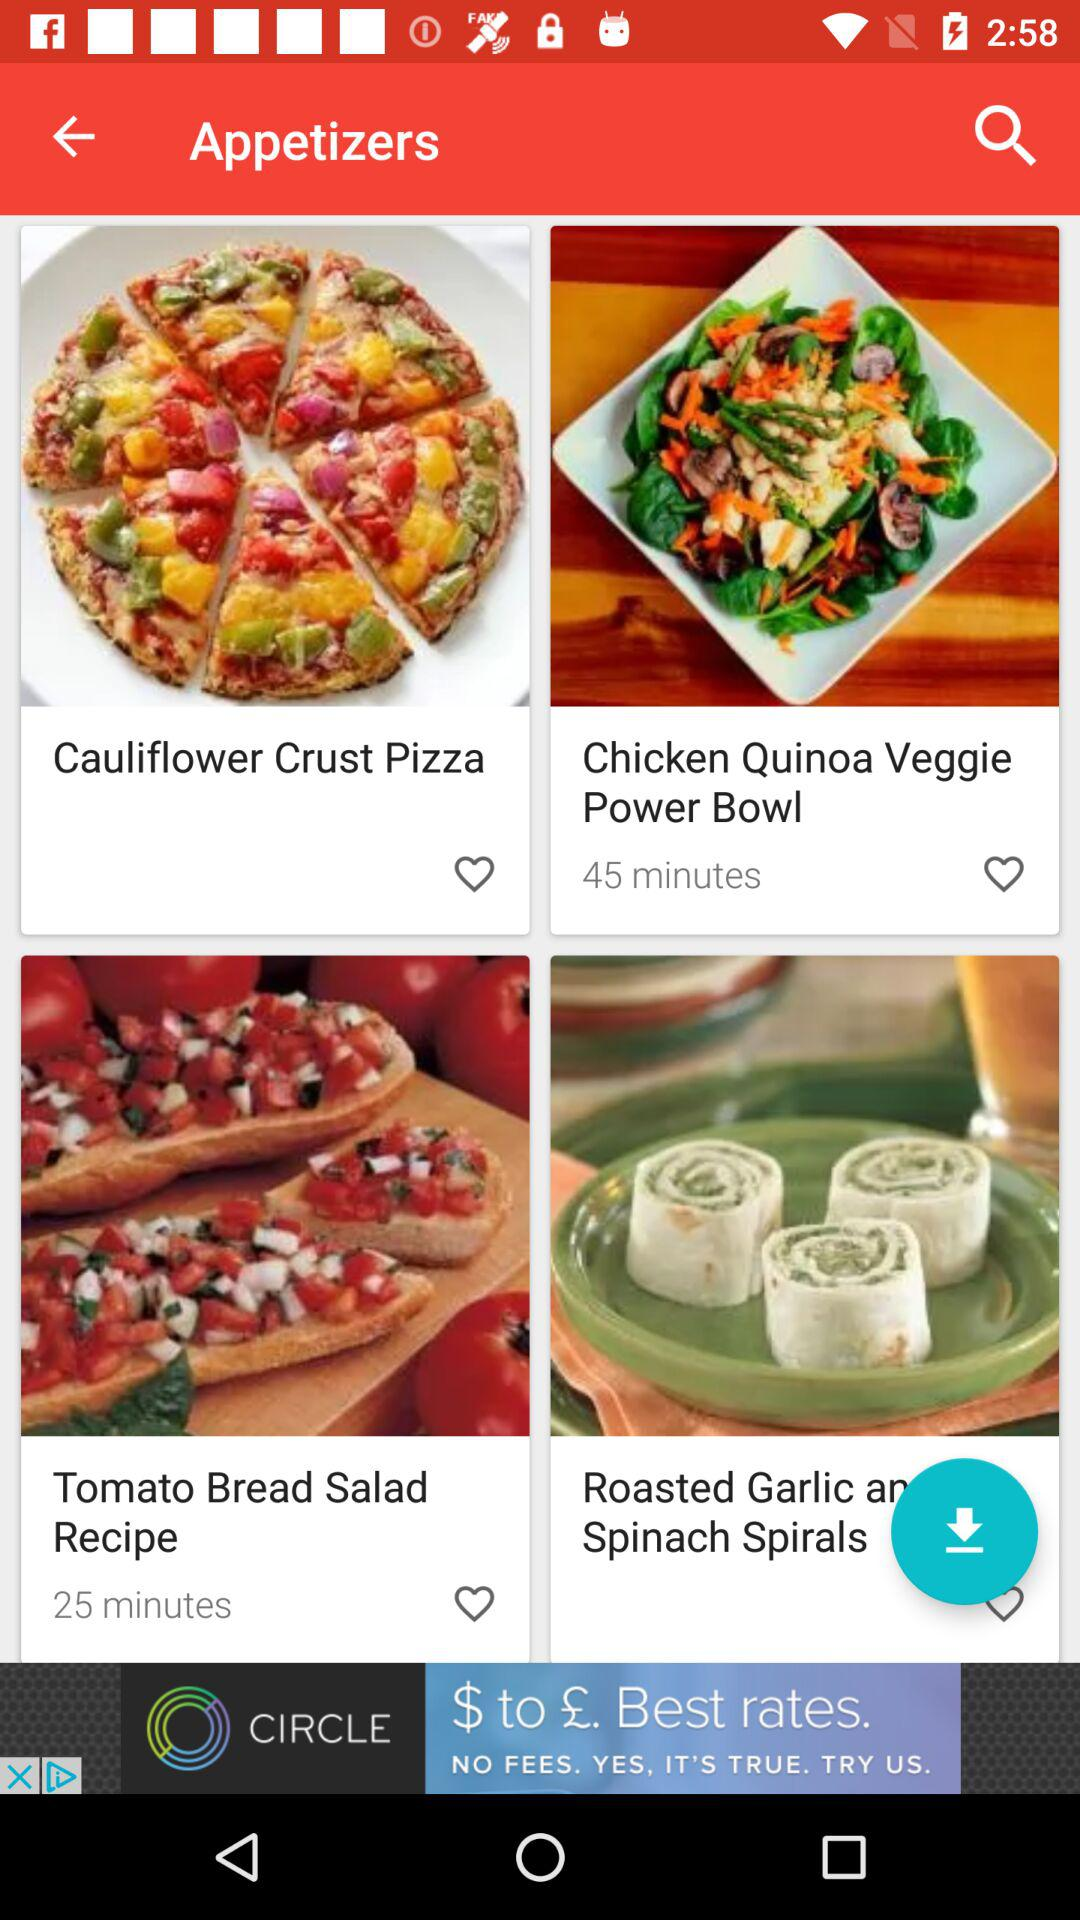What are the different appetizers? The different appetizers are "Cauliflower Crust Pizza", "Chicken Quinoa Veggie Power Bowl", "Tomato Bread Salad Recipe" and "Roasted Garlic an Spinach Spirals". 